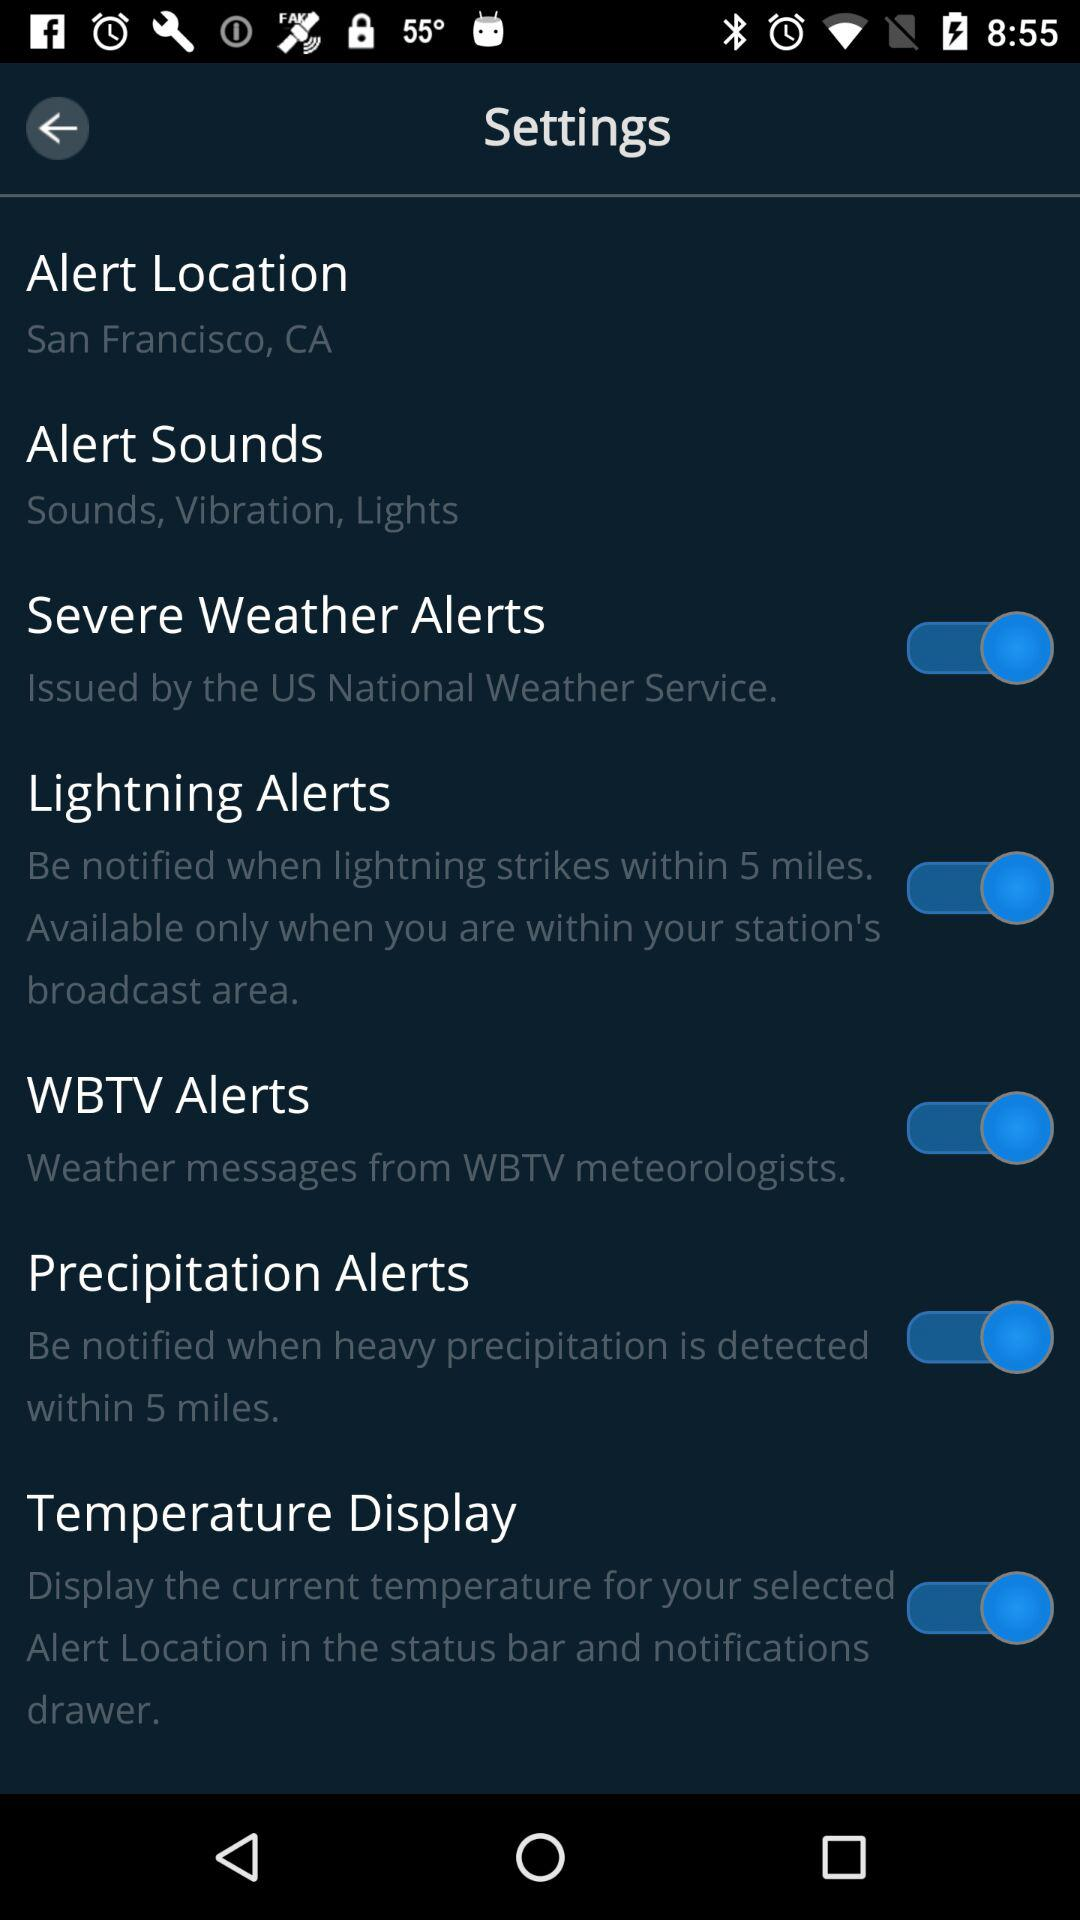What is the status of "Lightning Alerts"? The status is "on". 